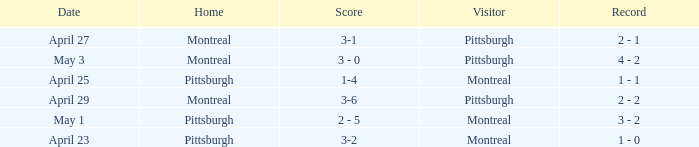Could you parse the entire table as a dict? {'header': ['Date', 'Home', 'Score', 'Visitor', 'Record'], 'rows': [['April 27', 'Montreal', '3-1', 'Pittsburgh', '2 - 1'], ['May 3', 'Montreal', '3 - 0', 'Pittsburgh', '4 - 2'], ['April 25', 'Pittsburgh', '1-4', 'Montreal', '1 - 1'], ['April 29', 'Montreal', '3-6', 'Pittsburgh', '2 - 2'], ['May 1', 'Pittsburgh', '2 - 5', 'Montreal', '3 - 2'], ['April 23', 'Pittsburgh', '3-2', 'Montreal', '1 - 0']]} What was the score on May 3? 3 - 0. 